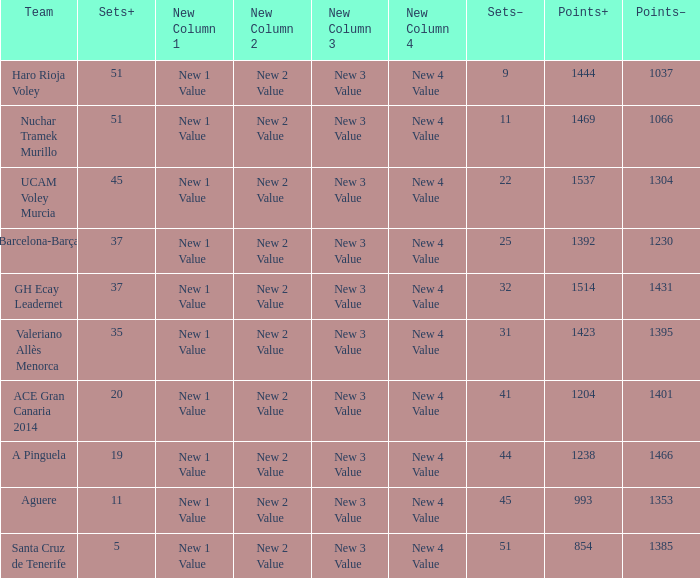What is the total number of Points- when the Sets- is larger than 51? 0.0. Could you parse the entire table as a dict? {'header': ['Team', 'Sets+', 'New Column 1', 'New Column 2', 'New Column 3', 'New Column 4', 'Sets–', 'Points+', 'Points–'], 'rows': [['Haro Rioja Voley', '51', 'New 1 Value', 'New 2 Value', 'New 3 Value', 'New 4 Value', '9', '1444', '1037'], ['Nuchar Tramek Murillo', '51', 'New 1 Value', 'New 2 Value', 'New 3 Value', 'New 4 Value', '11', '1469', '1066'], ['UCAM Voley Murcia', '45', 'New 1 Value', 'New 2 Value', 'New 3 Value', 'New 4 Value', '22', '1537', '1304'], ['Barcelona-Barça', '37', 'New 1 Value', 'New 2 Value', 'New 3 Value', 'New 4 Value', '25', '1392', '1230'], ['GH Ecay Leadernet', '37', 'New 1 Value', 'New 2 Value', 'New 3 Value', 'New 4 Value', '32', '1514', '1431'], ['Valeriano Allès Menorca', '35', 'New 1 Value', 'New 2 Value', 'New 3 Value', 'New 4 Value', '31', '1423', '1395'], ['ACE Gran Canaria 2014', '20', 'New 1 Value', 'New 2 Value', 'New 3 Value', 'New 4 Value', '41', '1204', '1401'], ['A Pinguela', '19', 'New 1 Value', 'New 2 Value', 'New 3 Value', 'New 4 Value', '44', '1238', '1466'], ['Aguere', '11', 'New 1 Value', 'New 2 Value', 'New 3 Value', 'New 4 Value', '45', '993', '1353'], ['Santa Cruz de Tenerife', '5', 'New 1 Value', 'New 2 Value', 'New 3 Value', 'New 4 Value', '51', '854', '1385']]} 